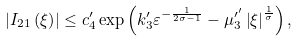Convert formula to latex. <formula><loc_0><loc_0><loc_500><loc_500>\left | I _ { 2 1 } \left ( \xi \right ) \right | \leq c _ { 4 } ^ { \prime } \exp \left ( k _ { 3 } ^ { \prime } \varepsilon ^ { - \frac { 1 } { 2 \sigma - 1 } } - \mu _ { 3 } ^ { \prime ^ { \prime } } \left | \xi \right | ^ { \frac { 1 } { \sigma } } \right ) ,</formula> 